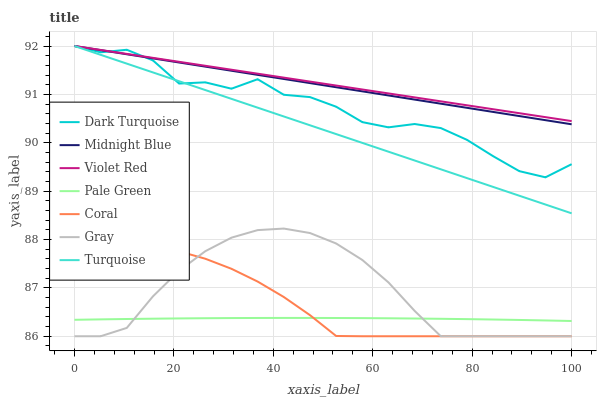Does Pale Green have the minimum area under the curve?
Answer yes or no. Yes. Does Violet Red have the maximum area under the curve?
Answer yes or no. Yes. Does Midnight Blue have the minimum area under the curve?
Answer yes or no. No. Does Midnight Blue have the maximum area under the curve?
Answer yes or no. No. Is Turquoise the smoothest?
Answer yes or no. Yes. Is Dark Turquoise the roughest?
Answer yes or no. Yes. Is Violet Red the smoothest?
Answer yes or no. No. Is Violet Red the roughest?
Answer yes or no. No. Does Gray have the lowest value?
Answer yes or no. Yes. Does Midnight Blue have the lowest value?
Answer yes or no. No. Does Turquoise have the highest value?
Answer yes or no. Yes. Does Coral have the highest value?
Answer yes or no. No. Is Pale Green less than Violet Red?
Answer yes or no. Yes. Is Violet Red greater than Pale Green?
Answer yes or no. Yes. Does Turquoise intersect Midnight Blue?
Answer yes or no. Yes. Is Turquoise less than Midnight Blue?
Answer yes or no. No. Is Turquoise greater than Midnight Blue?
Answer yes or no. No. Does Pale Green intersect Violet Red?
Answer yes or no. No. 